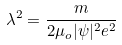Convert formula to latex. <formula><loc_0><loc_0><loc_500><loc_500>\lambda ^ { 2 } = \frac { m } { 2 \mu _ { o } | \psi | ^ { 2 } e ^ { 2 } }</formula> 